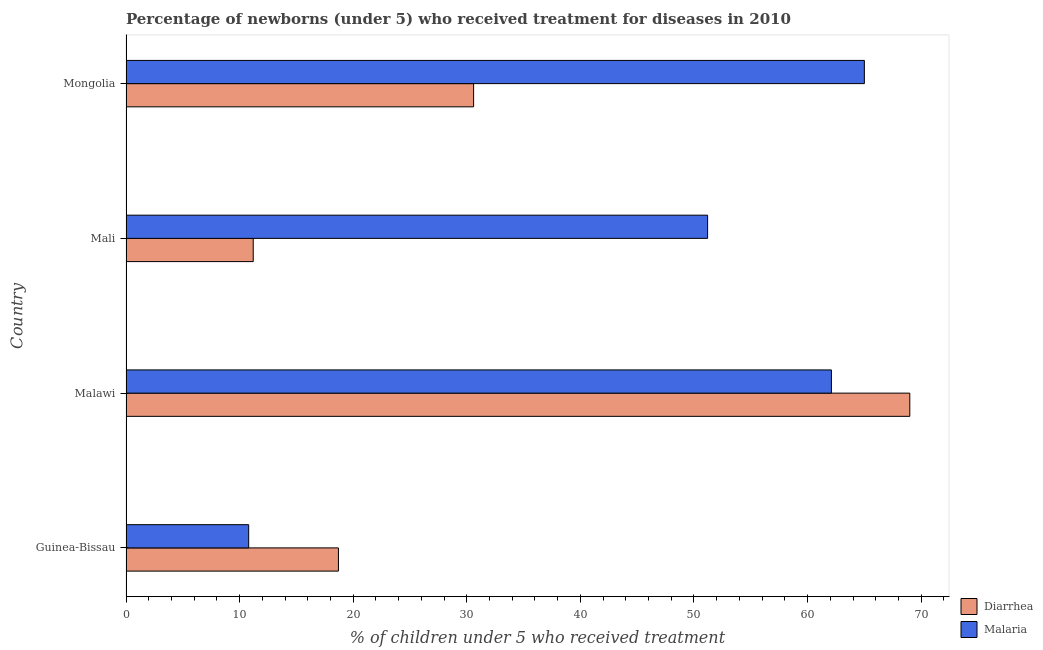How many different coloured bars are there?
Your answer should be very brief. 2. Are the number of bars on each tick of the Y-axis equal?
Your response must be concise. Yes. How many bars are there on the 2nd tick from the bottom?
Ensure brevity in your answer.  2. What is the label of the 3rd group of bars from the top?
Keep it short and to the point. Malawi. In how many cases, is the number of bars for a given country not equal to the number of legend labels?
Keep it short and to the point. 0. What is the percentage of children who received treatment for diarrhoea in Malawi?
Provide a succinct answer. 69. In which country was the percentage of children who received treatment for malaria maximum?
Your answer should be very brief. Mongolia. In which country was the percentage of children who received treatment for diarrhoea minimum?
Your response must be concise. Mali. What is the total percentage of children who received treatment for malaria in the graph?
Make the answer very short. 189.1. What is the difference between the percentage of children who received treatment for diarrhoea in Guinea-Bissau and that in Malawi?
Give a very brief answer. -50.3. What is the difference between the percentage of children who received treatment for malaria in Mali and the percentage of children who received treatment for diarrhoea in Malawi?
Your answer should be very brief. -17.8. What is the average percentage of children who received treatment for malaria per country?
Give a very brief answer. 47.27. What is the ratio of the percentage of children who received treatment for malaria in Guinea-Bissau to that in Mali?
Keep it short and to the point. 0.21. Is the difference between the percentage of children who received treatment for malaria in Guinea-Bissau and Mali greater than the difference between the percentage of children who received treatment for diarrhoea in Guinea-Bissau and Mali?
Your answer should be compact. No. What is the difference between the highest and the second highest percentage of children who received treatment for diarrhoea?
Give a very brief answer. 38.4. What is the difference between the highest and the lowest percentage of children who received treatment for diarrhoea?
Your answer should be very brief. 57.8. In how many countries, is the percentage of children who received treatment for malaria greater than the average percentage of children who received treatment for malaria taken over all countries?
Your response must be concise. 3. Is the sum of the percentage of children who received treatment for malaria in Malawi and Mali greater than the maximum percentage of children who received treatment for diarrhoea across all countries?
Your answer should be compact. Yes. What does the 1st bar from the top in Mongolia represents?
Give a very brief answer. Malaria. What does the 1st bar from the bottom in Malawi represents?
Ensure brevity in your answer.  Diarrhea. Are the values on the major ticks of X-axis written in scientific E-notation?
Your answer should be very brief. No. Does the graph contain any zero values?
Provide a short and direct response. No. Does the graph contain grids?
Offer a very short reply. No. How many legend labels are there?
Give a very brief answer. 2. How are the legend labels stacked?
Offer a terse response. Vertical. What is the title of the graph?
Your answer should be compact. Percentage of newborns (under 5) who received treatment for diseases in 2010. What is the label or title of the X-axis?
Offer a terse response. % of children under 5 who received treatment. What is the % of children under 5 who received treatment in Diarrhea in Guinea-Bissau?
Offer a very short reply. 18.7. What is the % of children under 5 who received treatment in Malaria in Guinea-Bissau?
Offer a very short reply. 10.8. What is the % of children under 5 who received treatment in Diarrhea in Malawi?
Your answer should be very brief. 69. What is the % of children under 5 who received treatment in Malaria in Malawi?
Ensure brevity in your answer.  62.1. What is the % of children under 5 who received treatment in Malaria in Mali?
Give a very brief answer. 51.2. What is the % of children under 5 who received treatment of Diarrhea in Mongolia?
Make the answer very short. 30.6. What is the % of children under 5 who received treatment in Malaria in Mongolia?
Provide a short and direct response. 65. Across all countries, what is the maximum % of children under 5 who received treatment of Malaria?
Ensure brevity in your answer.  65. Across all countries, what is the minimum % of children under 5 who received treatment in Malaria?
Your response must be concise. 10.8. What is the total % of children under 5 who received treatment in Diarrhea in the graph?
Your answer should be compact. 129.5. What is the total % of children under 5 who received treatment in Malaria in the graph?
Your answer should be compact. 189.1. What is the difference between the % of children under 5 who received treatment of Diarrhea in Guinea-Bissau and that in Malawi?
Offer a terse response. -50.3. What is the difference between the % of children under 5 who received treatment of Malaria in Guinea-Bissau and that in Malawi?
Give a very brief answer. -51.3. What is the difference between the % of children under 5 who received treatment of Malaria in Guinea-Bissau and that in Mali?
Ensure brevity in your answer.  -40.4. What is the difference between the % of children under 5 who received treatment of Diarrhea in Guinea-Bissau and that in Mongolia?
Your response must be concise. -11.9. What is the difference between the % of children under 5 who received treatment of Malaria in Guinea-Bissau and that in Mongolia?
Provide a short and direct response. -54.2. What is the difference between the % of children under 5 who received treatment in Diarrhea in Malawi and that in Mali?
Offer a terse response. 57.8. What is the difference between the % of children under 5 who received treatment in Malaria in Malawi and that in Mali?
Make the answer very short. 10.9. What is the difference between the % of children under 5 who received treatment in Diarrhea in Malawi and that in Mongolia?
Your answer should be very brief. 38.4. What is the difference between the % of children under 5 who received treatment in Malaria in Malawi and that in Mongolia?
Keep it short and to the point. -2.9. What is the difference between the % of children under 5 who received treatment of Diarrhea in Mali and that in Mongolia?
Your answer should be very brief. -19.4. What is the difference between the % of children under 5 who received treatment of Malaria in Mali and that in Mongolia?
Offer a very short reply. -13.8. What is the difference between the % of children under 5 who received treatment in Diarrhea in Guinea-Bissau and the % of children under 5 who received treatment in Malaria in Malawi?
Make the answer very short. -43.4. What is the difference between the % of children under 5 who received treatment in Diarrhea in Guinea-Bissau and the % of children under 5 who received treatment in Malaria in Mali?
Provide a succinct answer. -32.5. What is the difference between the % of children under 5 who received treatment in Diarrhea in Guinea-Bissau and the % of children under 5 who received treatment in Malaria in Mongolia?
Offer a terse response. -46.3. What is the difference between the % of children under 5 who received treatment of Diarrhea in Malawi and the % of children under 5 who received treatment of Malaria in Mongolia?
Provide a short and direct response. 4. What is the difference between the % of children under 5 who received treatment in Diarrhea in Mali and the % of children under 5 who received treatment in Malaria in Mongolia?
Your answer should be very brief. -53.8. What is the average % of children under 5 who received treatment in Diarrhea per country?
Make the answer very short. 32.38. What is the average % of children under 5 who received treatment in Malaria per country?
Your response must be concise. 47.27. What is the difference between the % of children under 5 who received treatment of Diarrhea and % of children under 5 who received treatment of Malaria in Guinea-Bissau?
Your answer should be compact. 7.9. What is the difference between the % of children under 5 who received treatment of Diarrhea and % of children under 5 who received treatment of Malaria in Mongolia?
Your answer should be compact. -34.4. What is the ratio of the % of children under 5 who received treatment in Diarrhea in Guinea-Bissau to that in Malawi?
Provide a short and direct response. 0.27. What is the ratio of the % of children under 5 who received treatment in Malaria in Guinea-Bissau to that in Malawi?
Give a very brief answer. 0.17. What is the ratio of the % of children under 5 who received treatment in Diarrhea in Guinea-Bissau to that in Mali?
Your response must be concise. 1.67. What is the ratio of the % of children under 5 who received treatment of Malaria in Guinea-Bissau to that in Mali?
Provide a succinct answer. 0.21. What is the ratio of the % of children under 5 who received treatment of Diarrhea in Guinea-Bissau to that in Mongolia?
Provide a succinct answer. 0.61. What is the ratio of the % of children under 5 who received treatment of Malaria in Guinea-Bissau to that in Mongolia?
Give a very brief answer. 0.17. What is the ratio of the % of children under 5 who received treatment of Diarrhea in Malawi to that in Mali?
Offer a very short reply. 6.16. What is the ratio of the % of children under 5 who received treatment of Malaria in Malawi to that in Mali?
Offer a terse response. 1.21. What is the ratio of the % of children under 5 who received treatment of Diarrhea in Malawi to that in Mongolia?
Give a very brief answer. 2.25. What is the ratio of the % of children under 5 who received treatment in Malaria in Malawi to that in Mongolia?
Keep it short and to the point. 0.96. What is the ratio of the % of children under 5 who received treatment of Diarrhea in Mali to that in Mongolia?
Provide a short and direct response. 0.37. What is the ratio of the % of children under 5 who received treatment in Malaria in Mali to that in Mongolia?
Provide a succinct answer. 0.79. What is the difference between the highest and the second highest % of children under 5 who received treatment of Diarrhea?
Keep it short and to the point. 38.4. What is the difference between the highest and the second highest % of children under 5 who received treatment in Malaria?
Offer a very short reply. 2.9. What is the difference between the highest and the lowest % of children under 5 who received treatment in Diarrhea?
Offer a terse response. 57.8. What is the difference between the highest and the lowest % of children under 5 who received treatment of Malaria?
Provide a short and direct response. 54.2. 